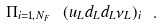<formula> <loc_0><loc_0><loc_500><loc_500>\Pi _ { i = 1 , N _ { F } } \ ( u _ { L } d _ { L } d _ { L } \nu _ { L } ) _ { i } \ .</formula> 